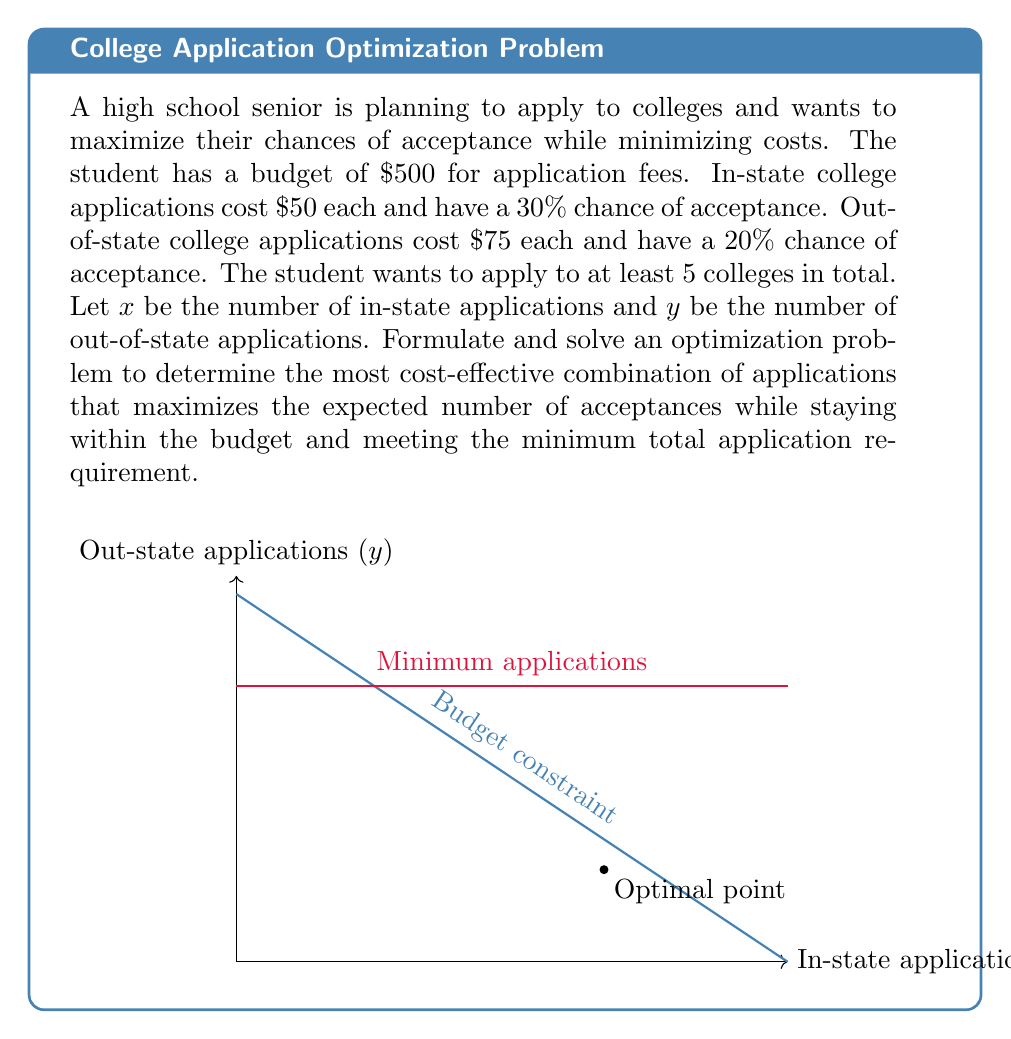Help me with this question. Let's approach this problem step-by-step:

1) First, we need to formulate our objective function. We want to maximize the expected number of acceptances:
   $$ \text{Maximize } Z = 0.3x + 0.2y $$

2) Now, we need to define our constraints:
   a) Budget constraint: $50x + 75y \leq 500$
   b) Minimum applications: $x + y \geq 5$
   c) Non-negativity: $x \geq 0, y \geq 0$

3) We can solve this using the graphical method. Let's plot our constraints:
   - Budget: $50x + 75y = 500$ or $y = \frac{20}{3} - \frac{2}{3}x$
   - Minimum applications: $y = 5 - x$

4) The feasible region is the area that satisfies all constraints. The optimal solution will be at one of the corner points of this region.

5) The corner points are:
   - (10, 0): where budget line meets x-axis
   - (0, 6.67): where budget line meets y-axis
   - (6.67, 1.67): intersection of budget and minimum application lines

6) Let's evaluate our objective function at these points:
   - Z(10, 0) = 0.3(10) + 0.2(0) = 3
   - Z(0, 6.67) = 0.3(0) + 0.2(6.67) = 1.33
   - Z(6.67, 1.67) = 0.3(6.67) + 0.2(1.67) = 2.33

7) The maximum value is at (10, 0), which means applying to 10 in-state colleges.

8) However, this doesn't meet our minimum of 5 total applications. The next best point that meets all constraints is (6.67, 1.67).

9) Rounding to whole numbers (as we can't apply to partial colleges), the optimal solution is 7 in-state applications and 2 out-of-state applications.
Answer: 7 in-state and 2 out-of-state applications 